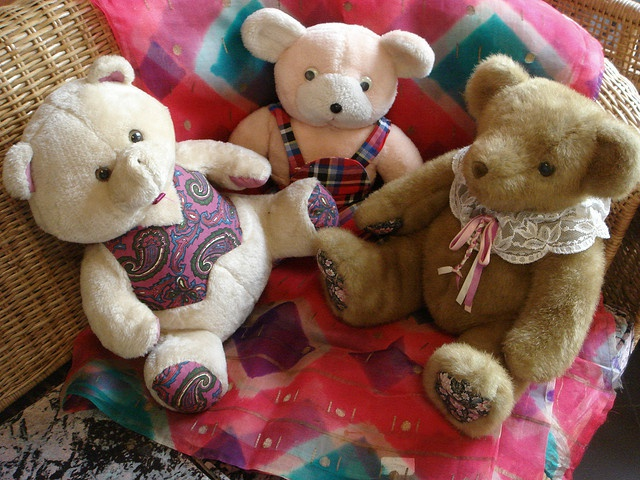Describe the objects in this image and their specific colors. I can see teddy bear in brown, maroon, olive, black, and gray tones, teddy bear in brown, lightgray, gray, and darkgray tones, and teddy bear in brown, gray, tan, lightgray, and darkgray tones in this image. 